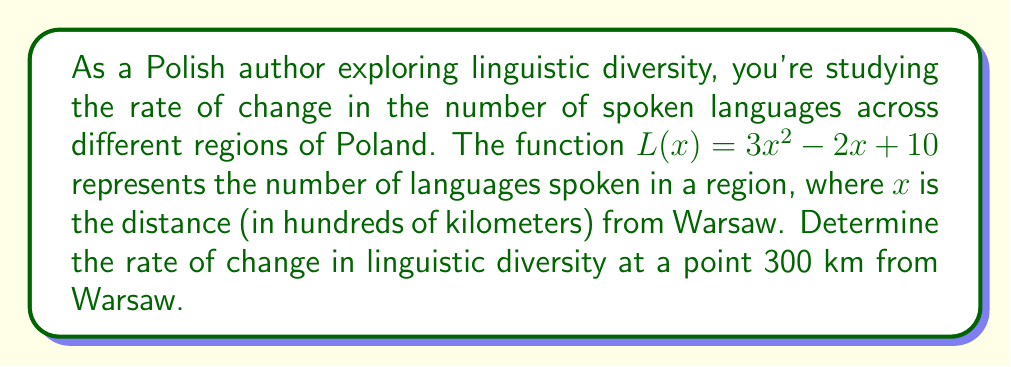Show me your answer to this math problem. To solve this problem, we need to follow these steps:

1) The rate of change in linguistic diversity is represented by the derivative of the function $L(x)$.

2) Let's find the derivative of $L(x) = 3x^2 - 2x + 10$:
   $$L'(x) = 6x - 2$$

3) We need to evaluate this at a point 300 km from Warsaw. In the function, $x$ is measured in hundreds of kilometers, so 300 km = 3 in our function.

4) Let's substitute $x = 3$ into our derivative function:
   $$L'(3) = 6(3) - 2 = 18 - 2 = 16$$

5) This means that at a point 300 km from Warsaw, the rate of change in linguistic diversity is 16 languages per 100 km.
Answer: 16 languages per 100 km 